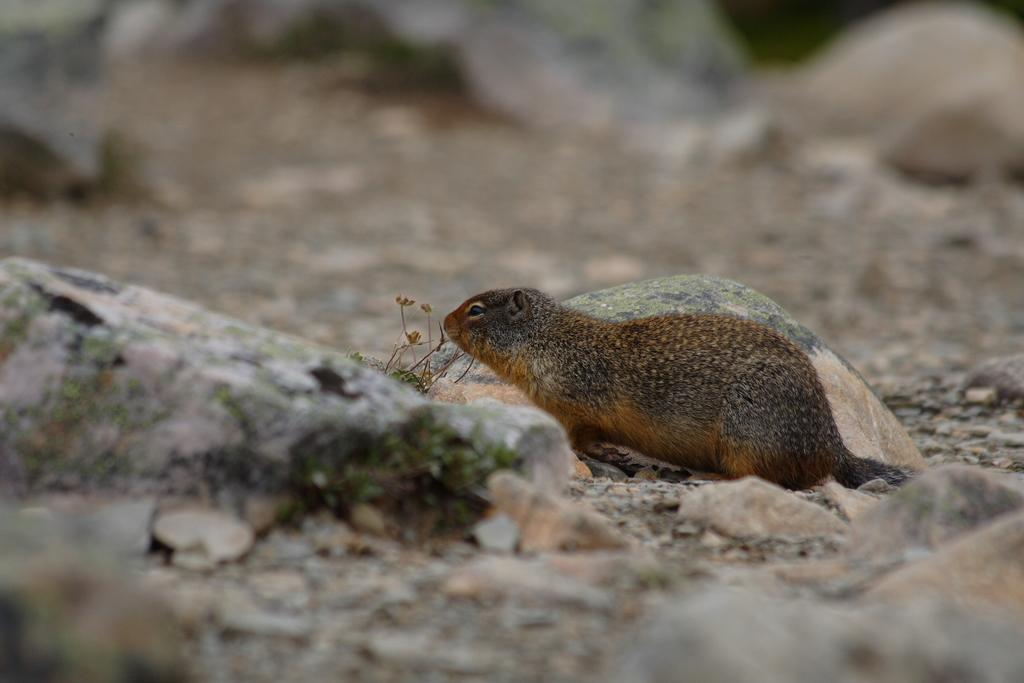What type of animal can be seen in the image? There is a squirrel in the image. What objects are located in the middle of the image? There are rocks in the middle of the image. Can you describe the background of the image? The background of the image is blurred. How many dinosaurs are visible in the image? There are no dinosaurs present in the image. What country is the image taken in? The provided facts do not mention the country where the image was taken. 